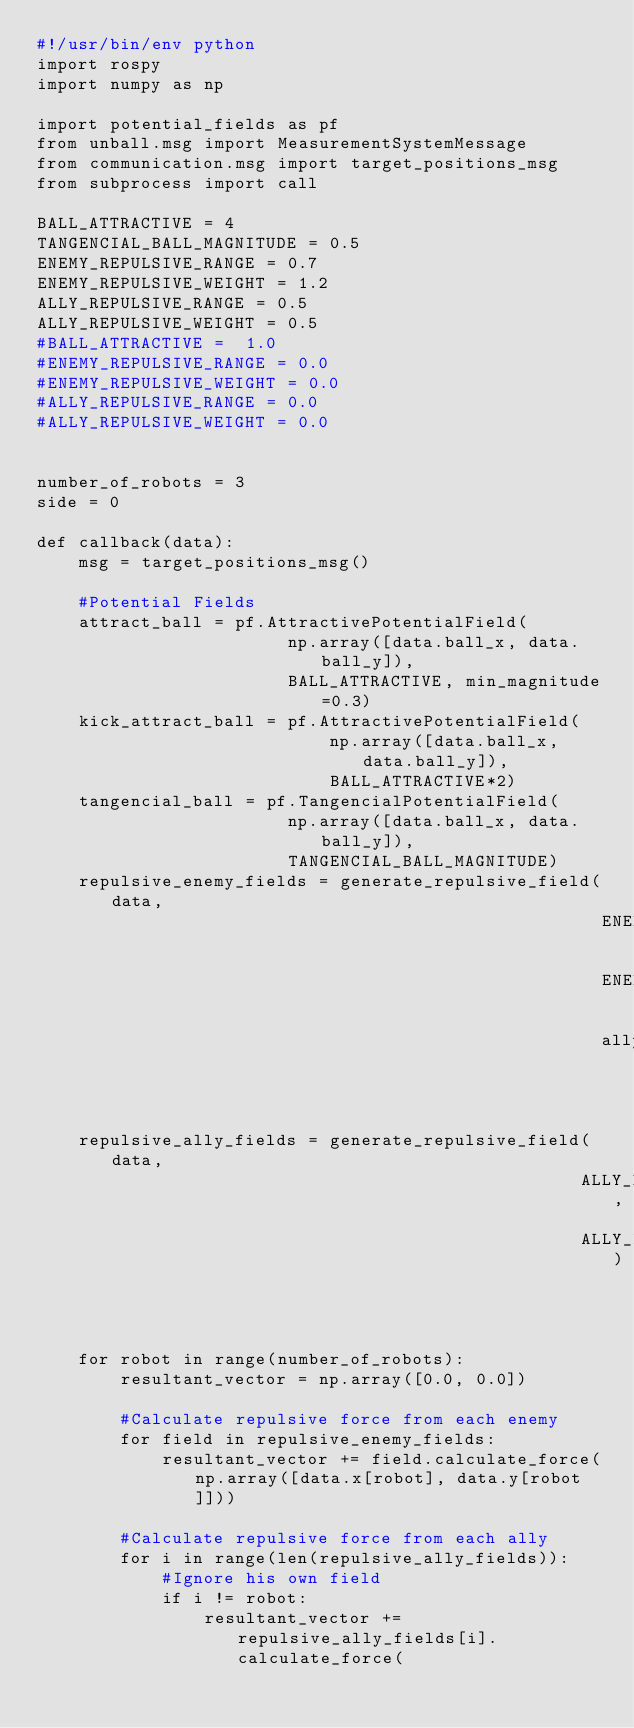<code> <loc_0><loc_0><loc_500><loc_500><_Python_>#!/usr/bin/env python
import rospy
import numpy as np

import potential_fields as pf
from unball.msg import MeasurementSystemMessage
from communication.msg import target_positions_msg
from subprocess import call

BALL_ATTRACTIVE = 4
TANGENCIAL_BALL_MAGNITUDE = 0.5
ENEMY_REPULSIVE_RANGE = 0.7
ENEMY_REPULSIVE_WEIGHT = 1.2
ALLY_REPULSIVE_RANGE = 0.5
ALLY_REPULSIVE_WEIGHT = 0.5
#BALL_ATTRACTIVE =  1.0
#ENEMY_REPULSIVE_RANGE = 0.0
#ENEMY_REPULSIVE_WEIGHT = 0.0
#ALLY_REPULSIVE_RANGE = 0.0
#ALLY_REPULSIVE_WEIGHT = 0.0


number_of_robots = 3
side = 0

def callback(data):
    msg = target_positions_msg()

    #Potential Fields
    attract_ball = pf.AttractivePotentialField(
                        np.array([data.ball_x, data.ball_y]),
                        BALL_ATTRACTIVE, min_magnitude=0.3)
    kick_attract_ball = pf.AttractivePotentialField(
                            np.array([data.ball_x, data.ball_y]),
                            BALL_ATTRACTIVE*2)
    tangencial_ball = pf.TangencialPotentialField(
                        np.array([data.ball_x, data.ball_y]),
                        TANGENCIAL_BALL_MAGNITUDE)
    repulsive_enemy_fields = generate_repulsive_field(data,
                                                      ENEMY_REPULSIVE_RANGE,
                                                      ENEMY_REPULSIVE_WEIGHT,
                                                      ally=False)
    repulsive_ally_fields = generate_repulsive_field(data,
                                                    ALLY_REPULSIVE_RANGE,
                                                    ALLY_REPULSIVE_WEIGHT)



    for robot in range(number_of_robots):
        resultant_vector = np.array([0.0, 0.0])

        #Calculate repulsive force from each enemy
        for field in repulsive_enemy_fields:
            resultant_vector += field.calculate_force(np.array([data.x[robot], data.y[robot]]))

        #Calculate repulsive force from each ally
        for i in range(len(repulsive_ally_fields)):
            #Ignore his own field
            if i != robot:
                resultant_vector += repulsive_ally_fields[i].calculate_force(</code> 